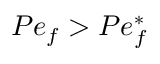Convert formula to latex. <formula><loc_0><loc_0><loc_500><loc_500>P e _ { f } > P e _ { f } ^ { \ast }</formula> 